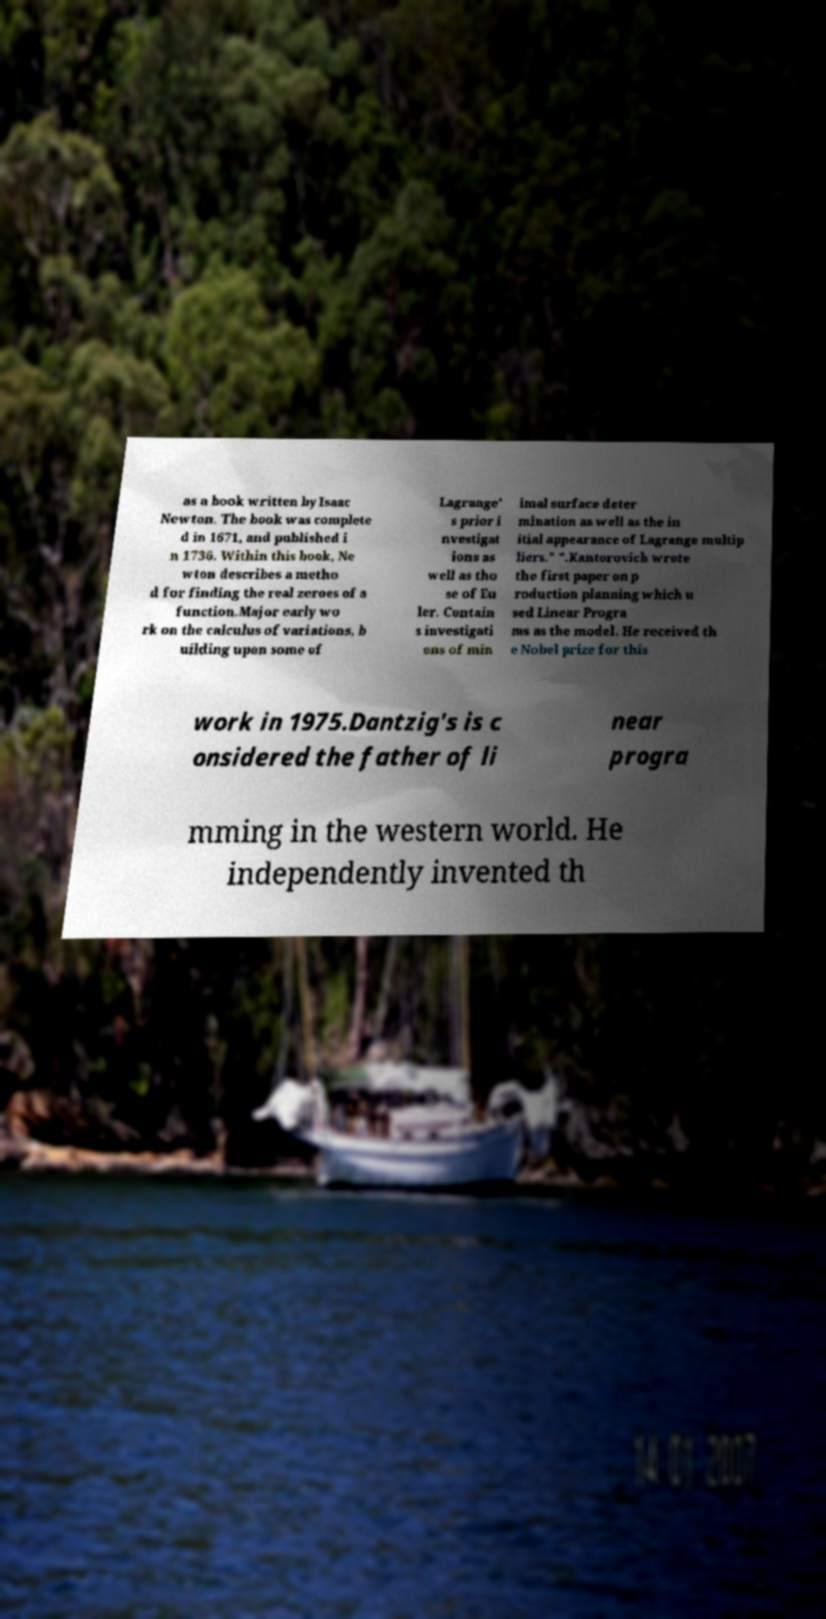I need the written content from this picture converted into text. Can you do that? as a book written by Isaac Newton. The book was complete d in 1671, and published i n 1736. Within this book, Ne wton describes a metho d for finding the real zeroes of a function.Major early wo rk on the calculus of variations, b uilding upon some of Lagrange' s prior i nvestigat ions as well as tho se of Eu ler. Contain s investigati ons of min imal surface deter mination as well as the in itial appearance of Lagrange multip liers." ".Kantorovich wrote the first paper on p roduction planning which u sed Linear Progra ms as the model. He received th e Nobel prize for this work in 1975.Dantzig's is c onsidered the father of li near progra mming in the western world. He independently invented th 